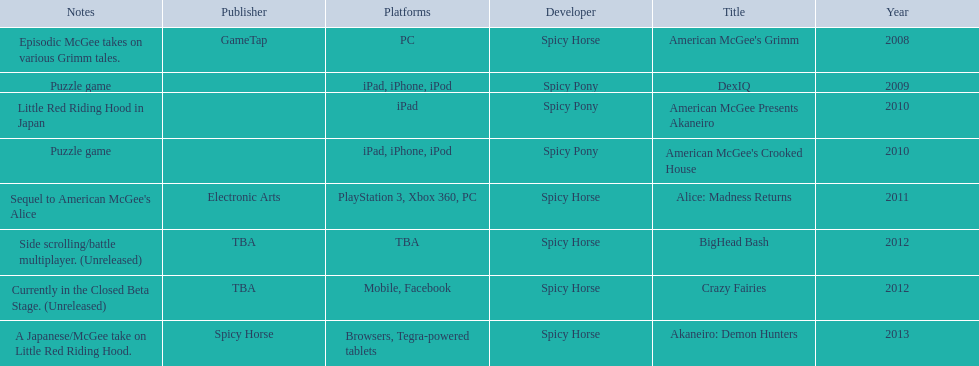Which spicy horse titles are shown? American McGee's Grimm, DexIQ, American McGee Presents Akaneiro, American McGee's Crooked House, Alice: Madness Returns, BigHead Bash, Crazy Fairies, Akaneiro: Demon Hunters. Of those, which are for the ipad? DexIQ, American McGee Presents Akaneiro, American McGee's Crooked House. Which of those are not for the iphone or ipod? American McGee Presents Akaneiro. 